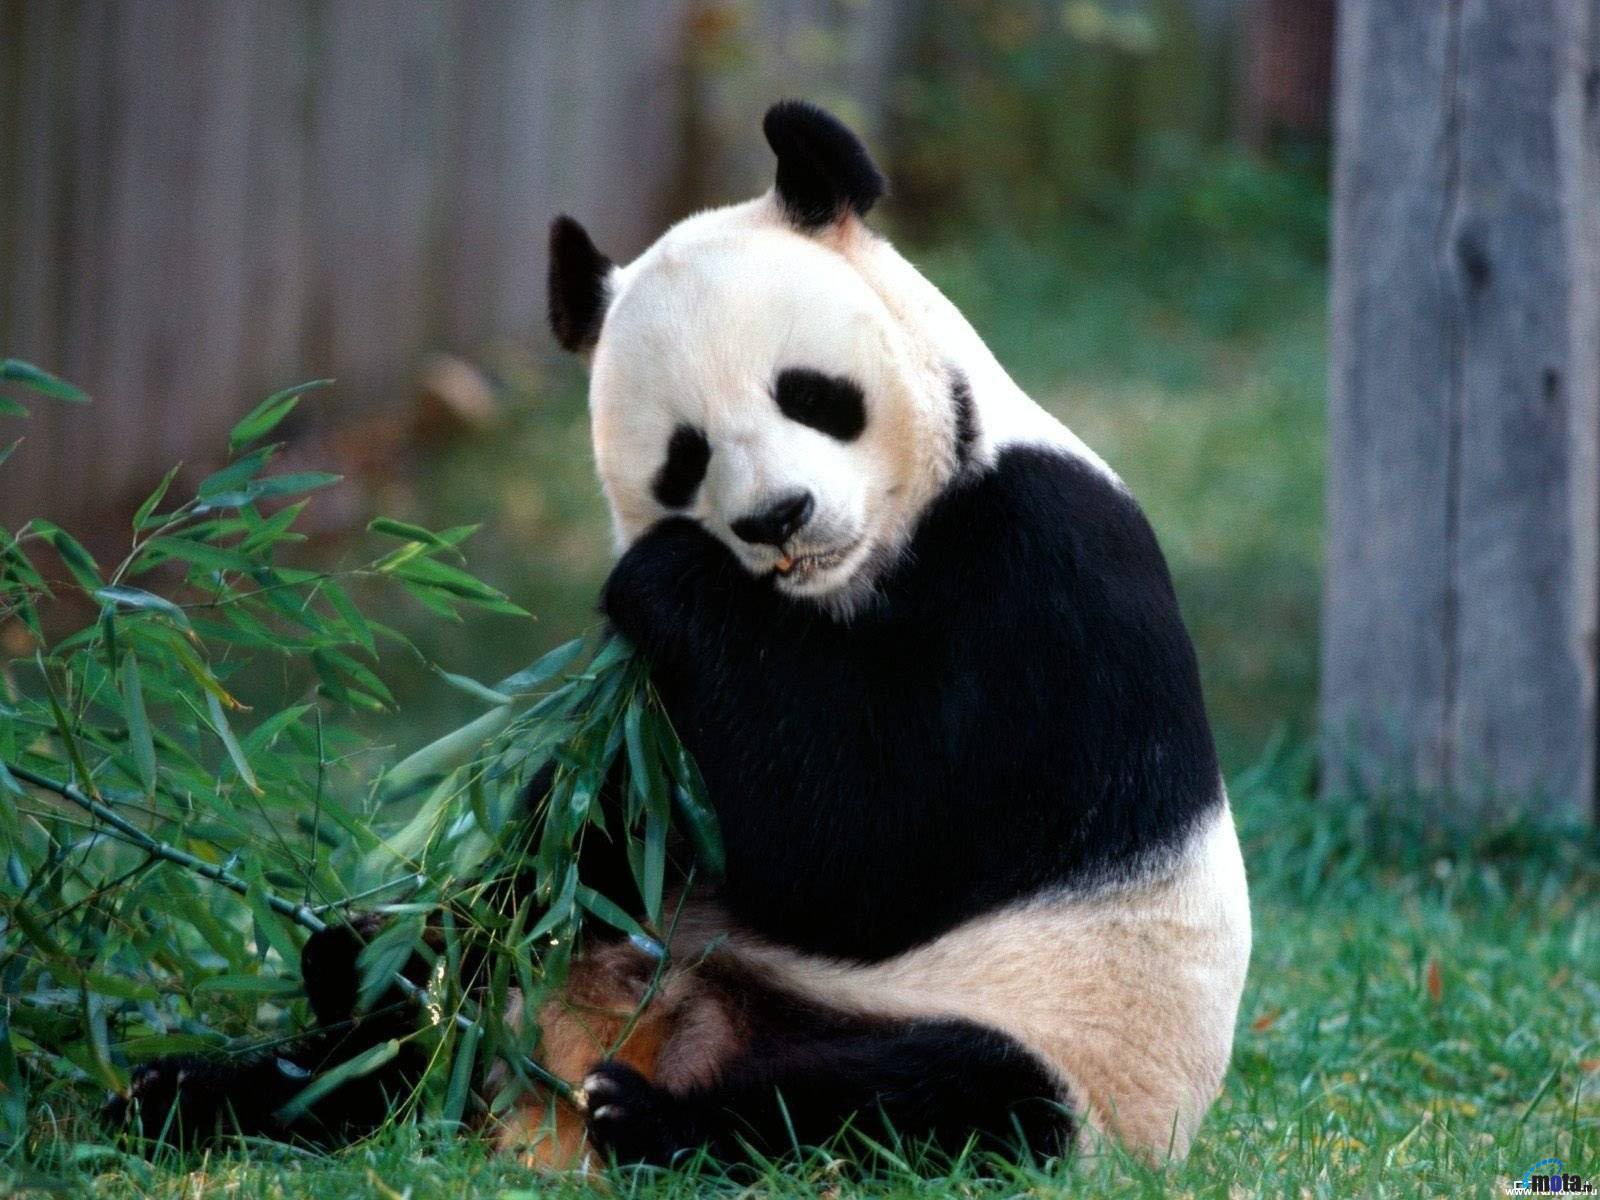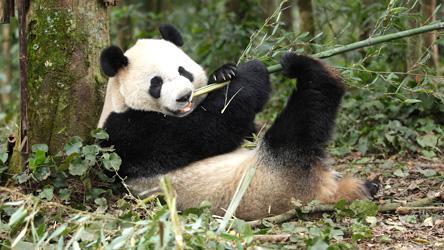The first image is the image on the left, the second image is the image on the right. Given the left and right images, does the statement "There are three pandas" hold true? Answer yes or no. No. 